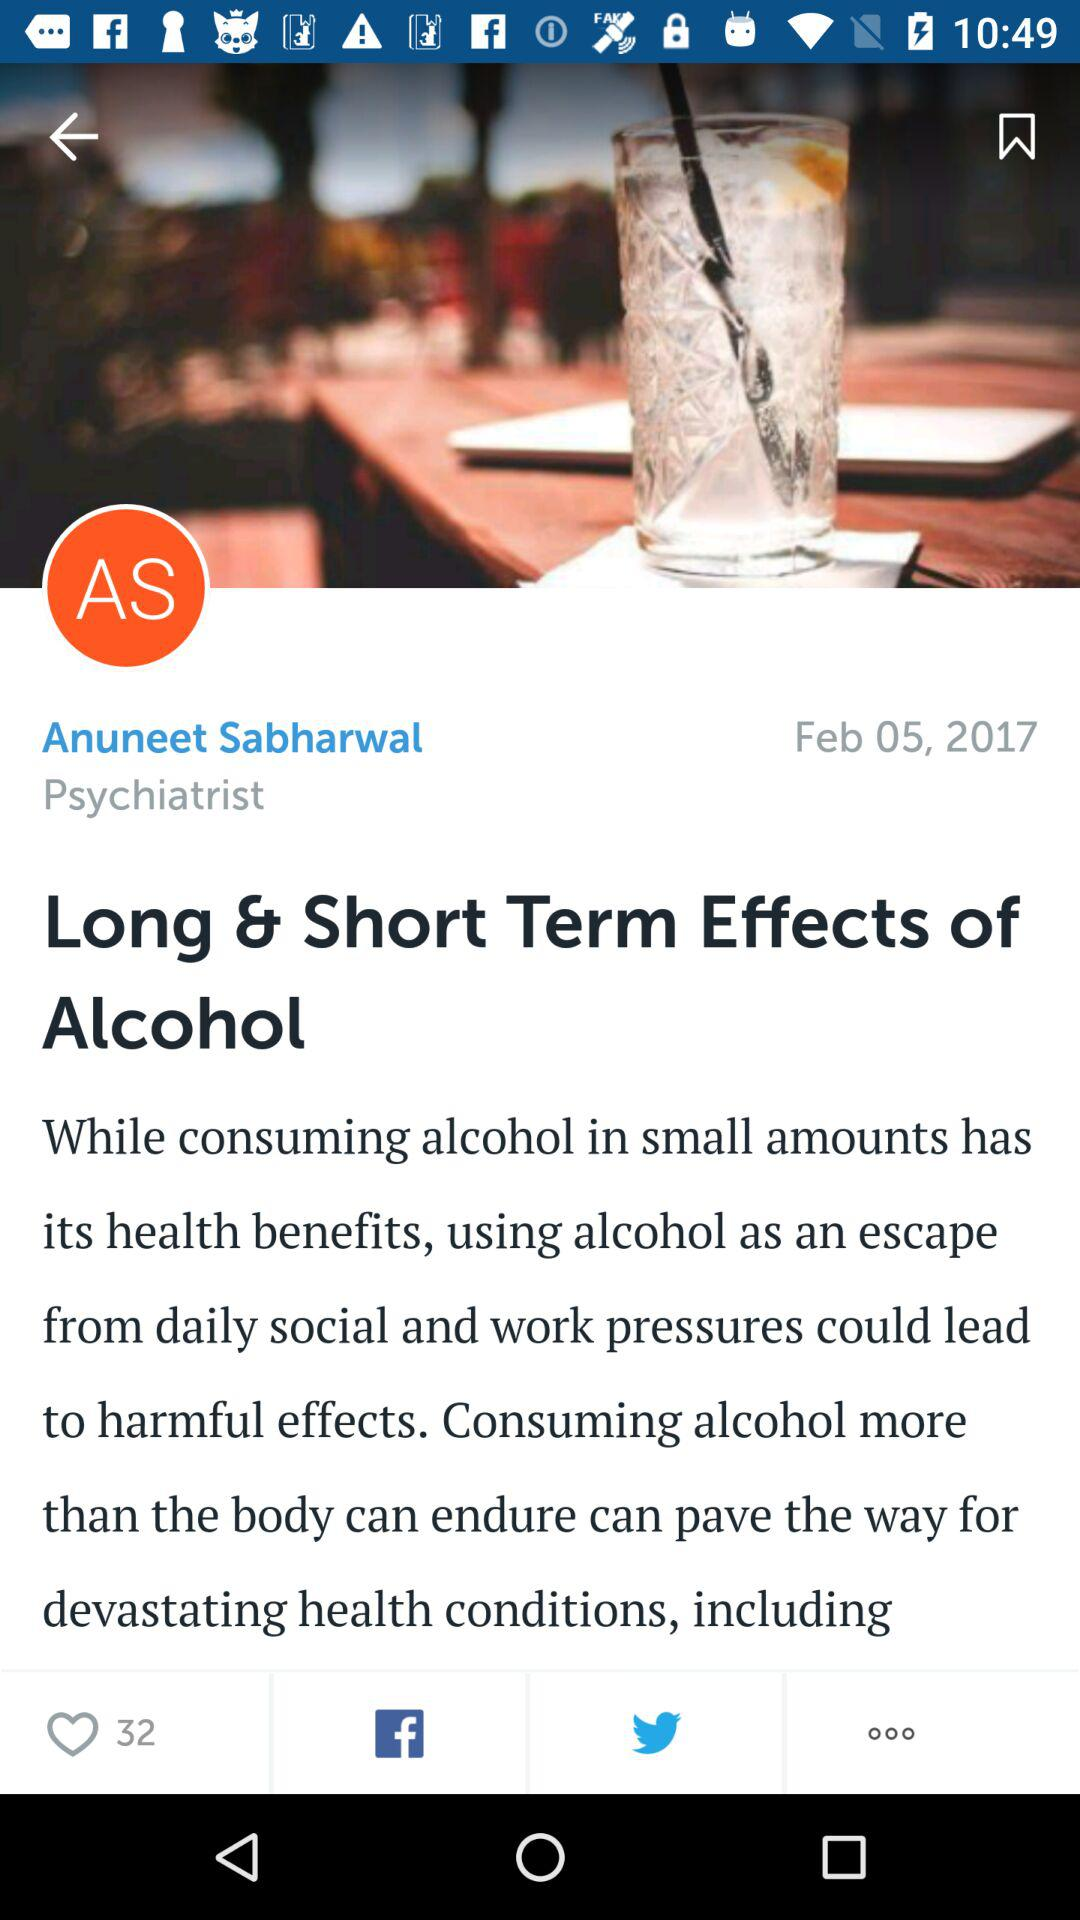What is the name of the psychiatrist? The name of the psychiatrist is Anuneet Sabharwal. 